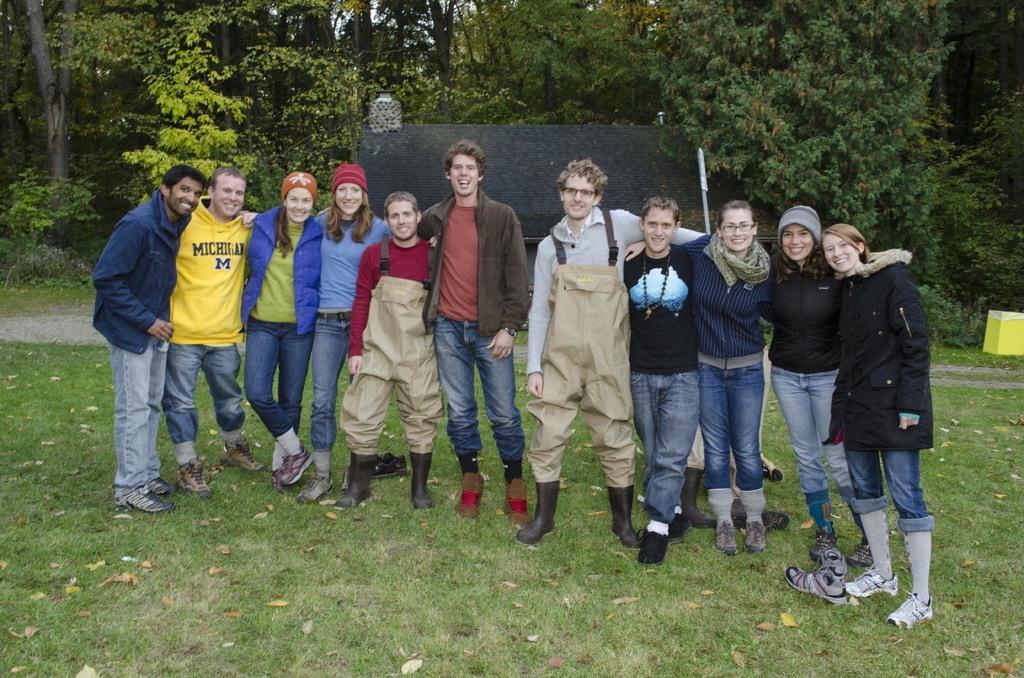Can you describe this image briefly? In this picture we can see group of people, few people are smiling and they are standing on the grass, in the background we can see few trees. 